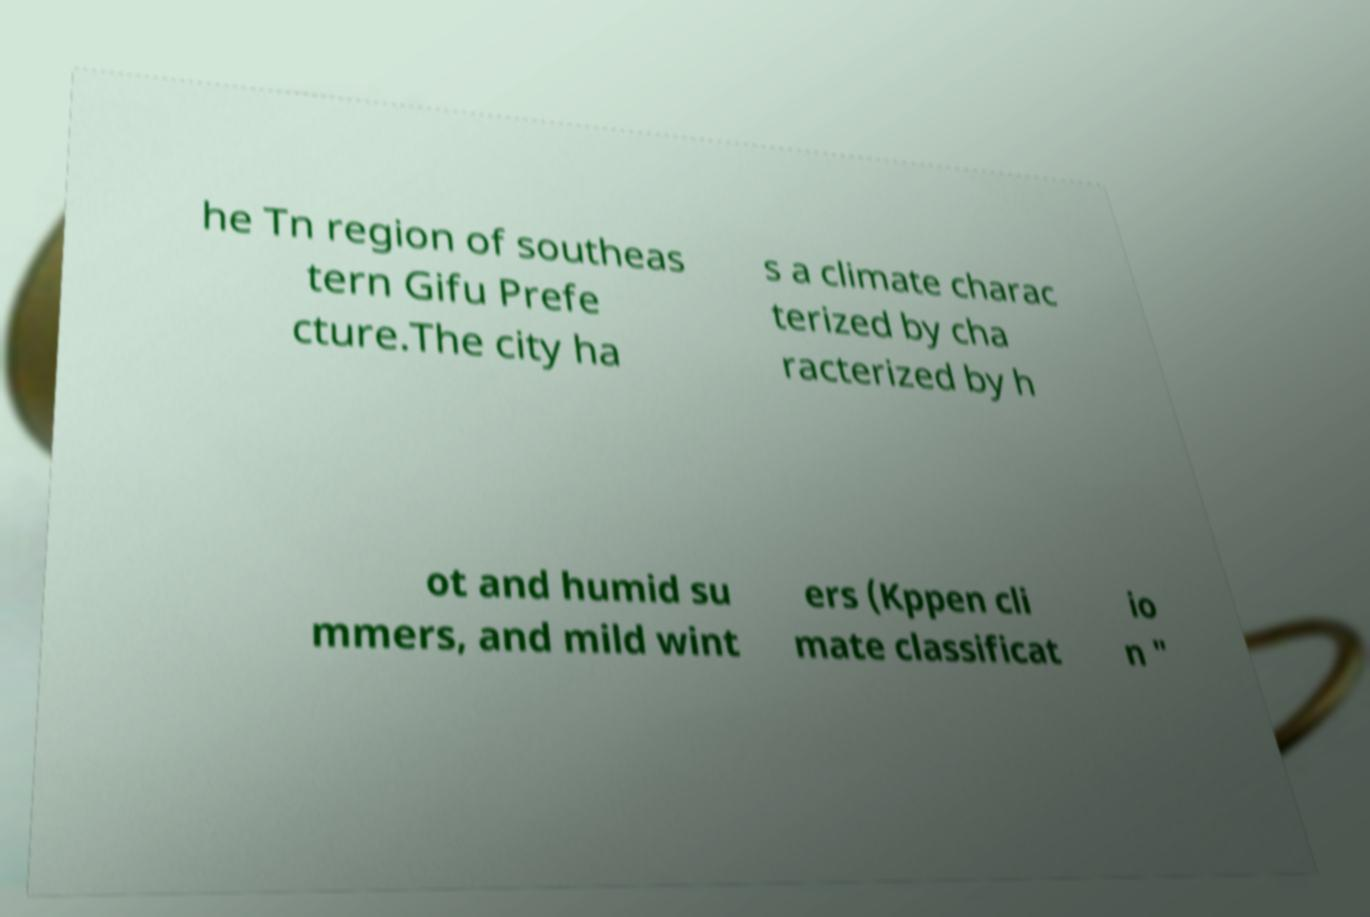Please identify and transcribe the text found in this image. he Tn region of southeas tern Gifu Prefe cture.The city ha s a climate charac terized by cha racterized by h ot and humid su mmers, and mild wint ers (Kppen cli mate classificat io n " 